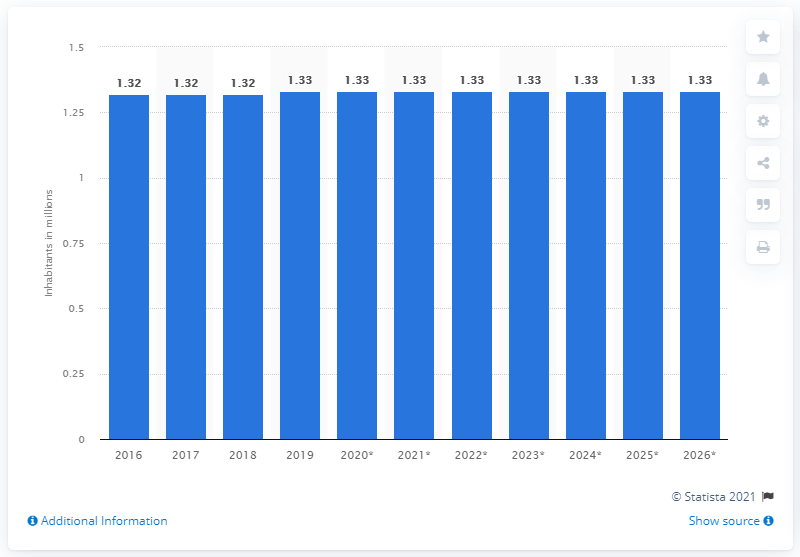Point out several critical features in this image. In 2019, the population of Estonia was approximately 1.33 million people. 